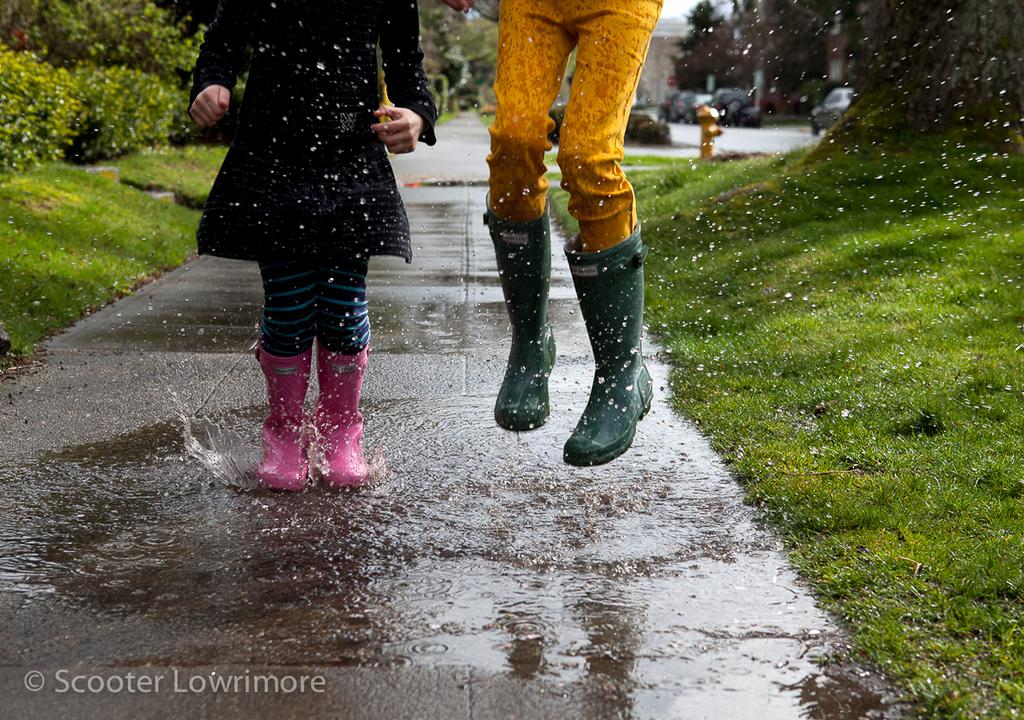What is the person in the water doing? The person standing in the water is not doing any specific action mentioned in the facts. What is the person doing in the image? There is a person jumping in the image. What type of vegetation can be seen in the image? There is grass and plants visible in the image. What else can be seen in the image besides the person jumping? Vehicles and trees are present in the image. What type of glove is being used to harvest the popcorn in the image? There is no glove or popcorn present in the image. What type of plantation can be seen in the image? There is no plantation present in the image. 